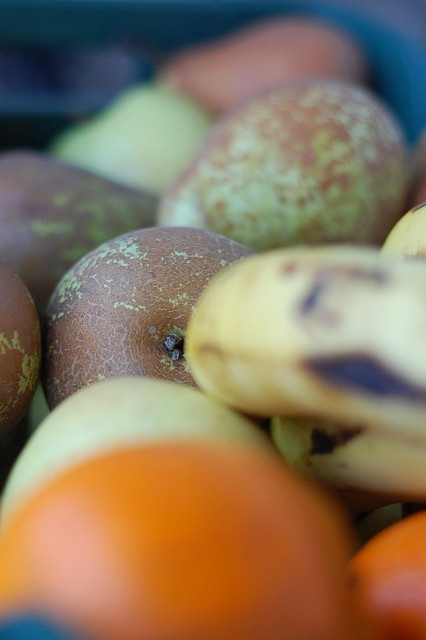Describe the objects in this image and their specific colors. I can see orange in blue, brown, red, tan, and salmon tones, banana in blue, beige, tan, and darkgray tones, and apple in blue, darkgray, and gray tones in this image. 